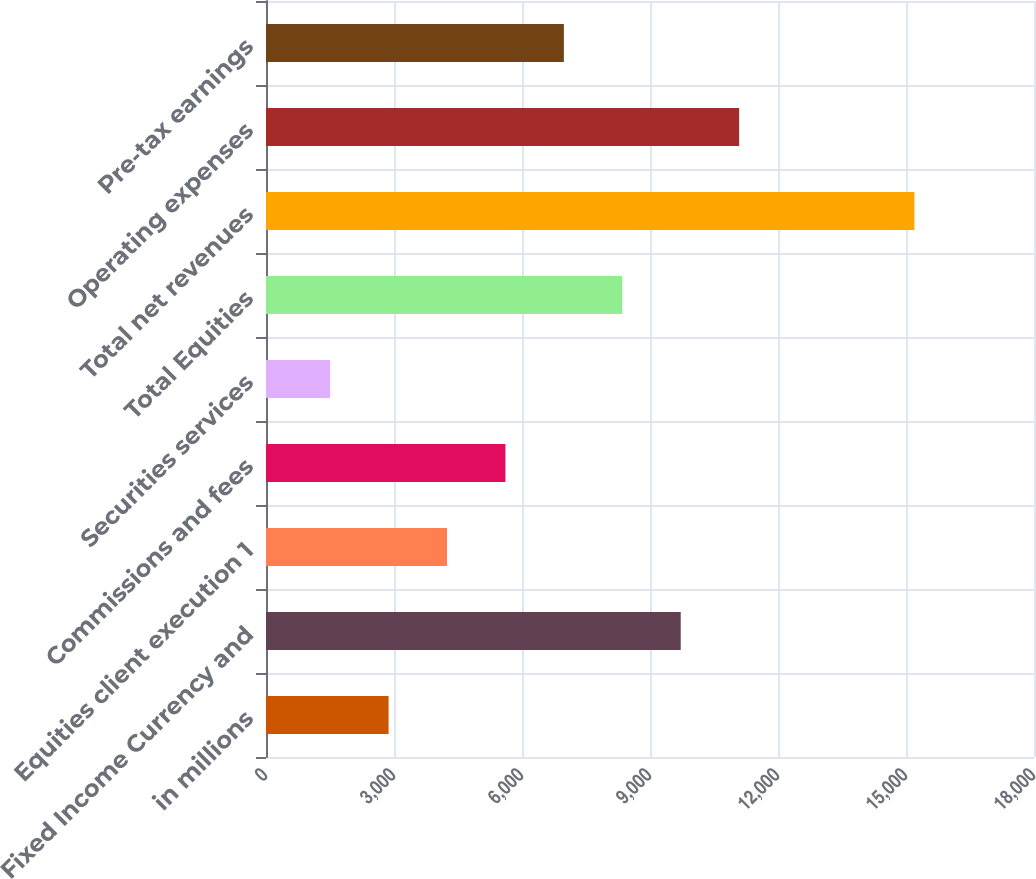Convert chart to OTSL. <chart><loc_0><loc_0><loc_500><loc_500><bar_chart><fcel>in millions<fcel>Fixed Income Currency and<fcel>Equities client execution 1<fcel>Commissions and fees<fcel>Securities services<fcel>Total Equities<fcel>Total net revenues<fcel>Operating expenses<fcel>Pre-tax earnings<nl><fcel>2873.3<fcel>9719.8<fcel>4242.6<fcel>5611.9<fcel>1504<fcel>8350.5<fcel>15197<fcel>11089.1<fcel>6981.2<nl></chart> 